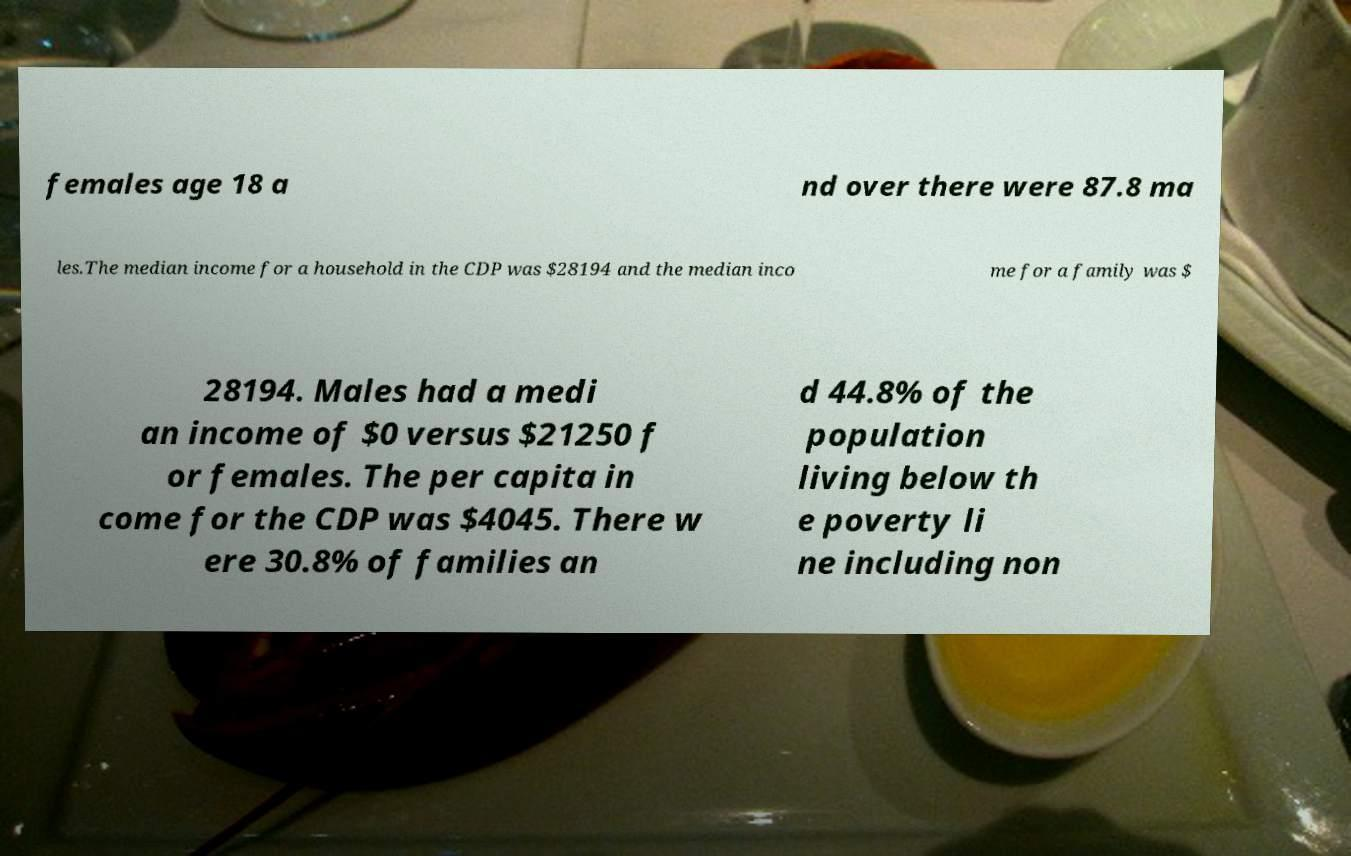What messages or text are displayed in this image? I need them in a readable, typed format. females age 18 a nd over there were 87.8 ma les.The median income for a household in the CDP was $28194 and the median inco me for a family was $ 28194. Males had a medi an income of $0 versus $21250 f or females. The per capita in come for the CDP was $4045. There w ere 30.8% of families an d 44.8% of the population living below th e poverty li ne including non 